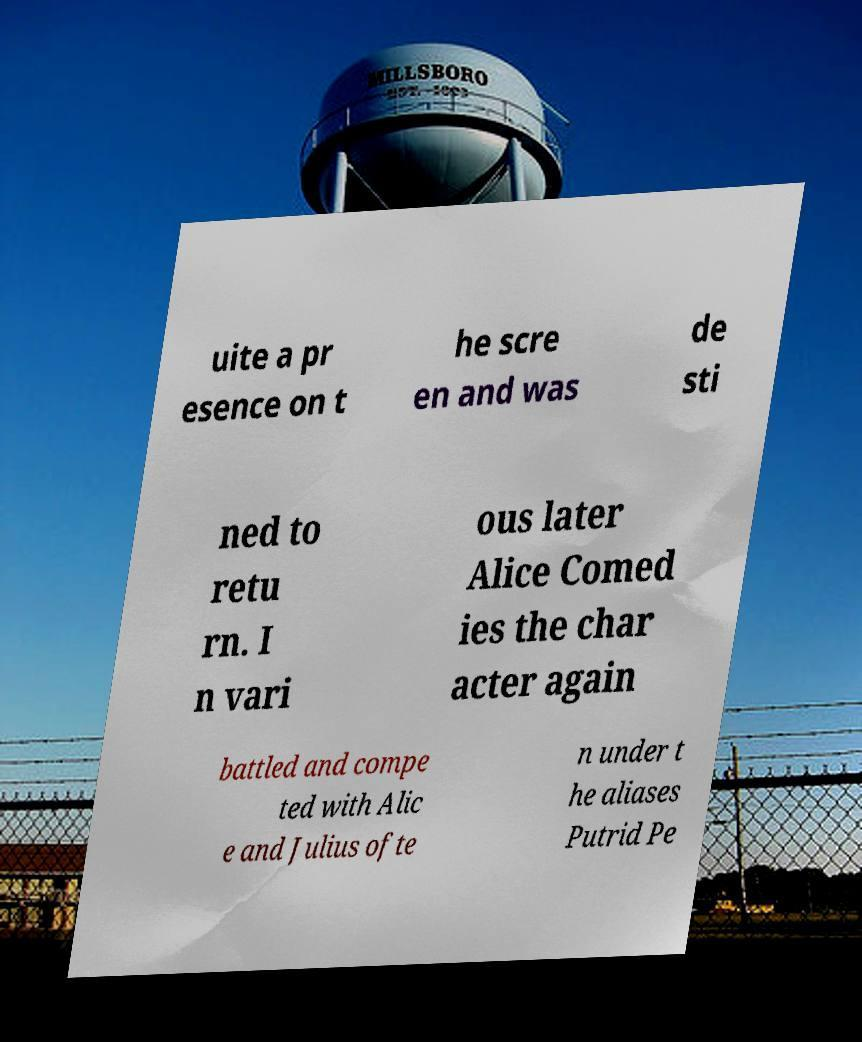Please read and relay the text visible in this image. What does it say? uite a pr esence on t he scre en and was de sti ned to retu rn. I n vari ous later Alice Comed ies the char acter again battled and compe ted with Alic e and Julius ofte n under t he aliases Putrid Pe 